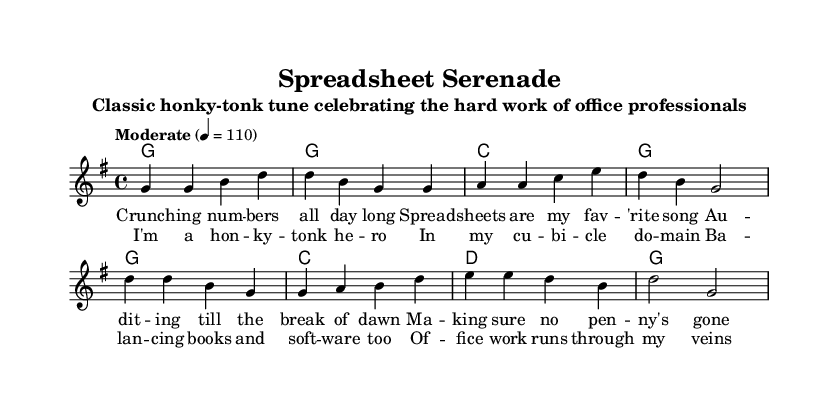What is the key signature of this music? The key signature is G major, which has one sharp (F#). It can be identified by looking for any sharps or flats at the beginning of the staff.
Answer: G major What is the time signature of this piece? The time signature is 4/4, which indicates that there are four beats in each measure and a quarter note gets one beat. This is typically found at the beginning of the music.
Answer: 4/4 What is the tempo marking for this piece? The tempo marking is "Moderate," with a specified tempo of 110 beats per minute, which is indicated in the tempo section.
Answer: Moderate How many measures are in the verse section? There are four measures in the verse section, as counted from the beginning to the end of the verse line.
Answer: Four What is the final note of the melody? The final note of the melody is G, which can be found by inspecting the last note in the melody line.
Answer: G What do the lyrics in the chorus celebrate? The lyrics in the chorus celebrate the experience and pride of being an office professional working with financial tasks. This can be inferred by looking at the thematic content of the lyrics provided.
Answer: Office work Which musical style does this piece represent? This piece represents the honky-tonk style, a subgenre of country music that often features piano and a lively rhythm suitable for dancing. This can be deduced from the title and the characteristic chord progressions.
Answer: Honky-tonk 